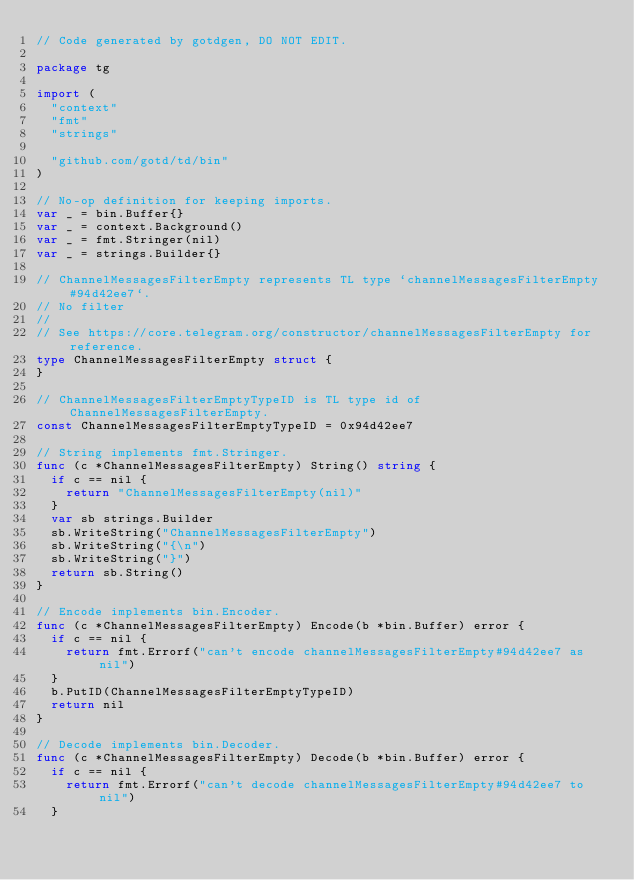Convert code to text. <code><loc_0><loc_0><loc_500><loc_500><_Go_>// Code generated by gotdgen, DO NOT EDIT.

package tg

import (
	"context"
	"fmt"
	"strings"

	"github.com/gotd/td/bin"
)

// No-op definition for keeping imports.
var _ = bin.Buffer{}
var _ = context.Background()
var _ = fmt.Stringer(nil)
var _ = strings.Builder{}

// ChannelMessagesFilterEmpty represents TL type `channelMessagesFilterEmpty#94d42ee7`.
// No filter
//
// See https://core.telegram.org/constructor/channelMessagesFilterEmpty for reference.
type ChannelMessagesFilterEmpty struct {
}

// ChannelMessagesFilterEmptyTypeID is TL type id of ChannelMessagesFilterEmpty.
const ChannelMessagesFilterEmptyTypeID = 0x94d42ee7

// String implements fmt.Stringer.
func (c *ChannelMessagesFilterEmpty) String() string {
	if c == nil {
		return "ChannelMessagesFilterEmpty(nil)"
	}
	var sb strings.Builder
	sb.WriteString("ChannelMessagesFilterEmpty")
	sb.WriteString("{\n")
	sb.WriteString("}")
	return sb.String()
}

// Encode implements bin.Encoder.
func (c *ChannelMessagesFilterEmpty) Encode(b *bin.Buffer) error {
	if c == nil {
		return fmt.Errorf("can't encode channelMessagesFilterEmpty#94d42ee7 as nil")
	}
	b.PutID(ChannelMessagesFilterEmptyTypeID)
	return nil
}

// Decode implements bin.Decoder.
func (c *ChannelMessagesFilterEmpty) Decode(b *bin.Buffer) error {
	if c == nil {
		return fmt.Errorf("can't decode channelMessagesFilterEmpty#94d42ee7 to nil")
	}</code> 